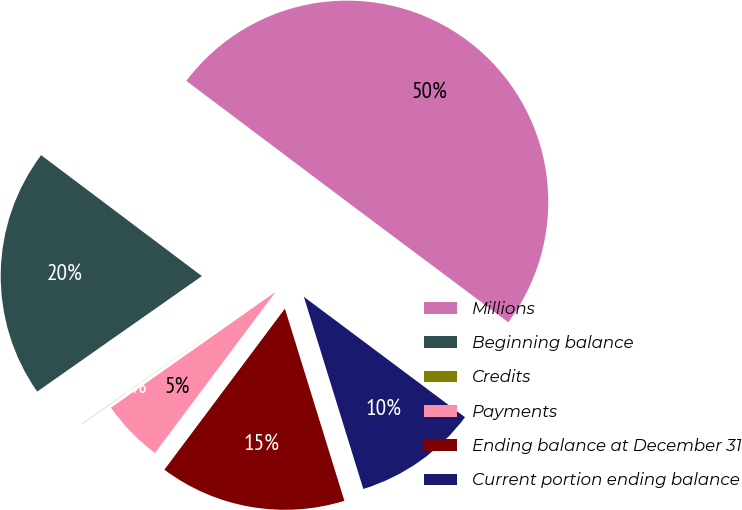Convert chart to OTSL. <chart><loc_0><loc_0><loc_500><loc_500><pie_chart><fcel>Millions<fcel>Beginning balance<fcel>Credits<fcel>Payments<fcel>Ending balance at December 31<fcel>Current portion ending balance<nl><fcel>49.95%<fcel>20.0%<fcel>0.02%<fcel>5.02%<fcel>15.0%<fcel>10.01%<nl></chart> 